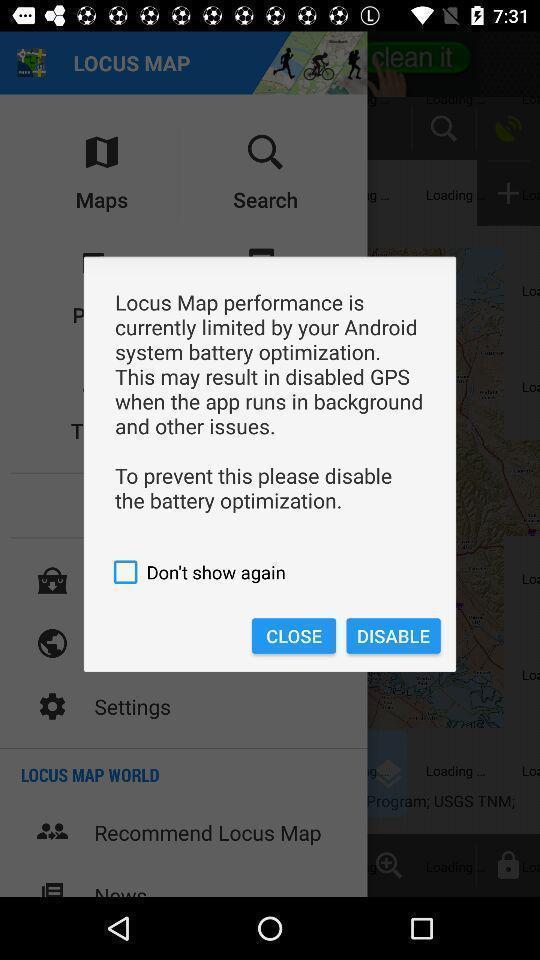What details can you identify in this image? Pop-up showing tips for the location app. 